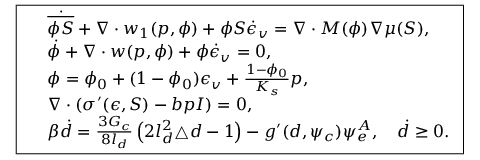Convert formula to latex. <formula><loc_0><loc_0><loc_500><loc_500>\boxed { \begin{array} { r l } & { \dot { \overline { \phi S } } + \nabla \cdot w _ { 1 } ( p , \phi ) + \phi S \dot { \epsilon } _ { v } = \nabla \cdot M ( \phi ) \nabla \mu ( S ) , } \\ & { \dot { \phi } + \nabla \cdot w ( p , \phi ) + \phi \dot { \epsilon } _ { v } = 0 , } \\ & { \phi = \phi _ { 0 } + ( 1 - \phi _ { 0 } ) \epsilon _ { v } + \frac { 1 - \phi _ { 0 } } { K _ { s } } p , } \\ & { \nabla \cdot \left ( \sigma ^ { \prime } ( \epsilon , S ) - b p I \right ) = 0 , } \\ & { \beta \dot { d } = \frac { 3 G _ { c } } { 8 l _ { d } } \left ( 2 l _ { d } ^ { 2 } \triangle { d } - 1 \right ) - g ^ { \prime } ( d , \psi _ { c } ) \psi _ { e } ^ { A } , \quad \dot { d } \geq 0 . } \end{array} }</formula> 